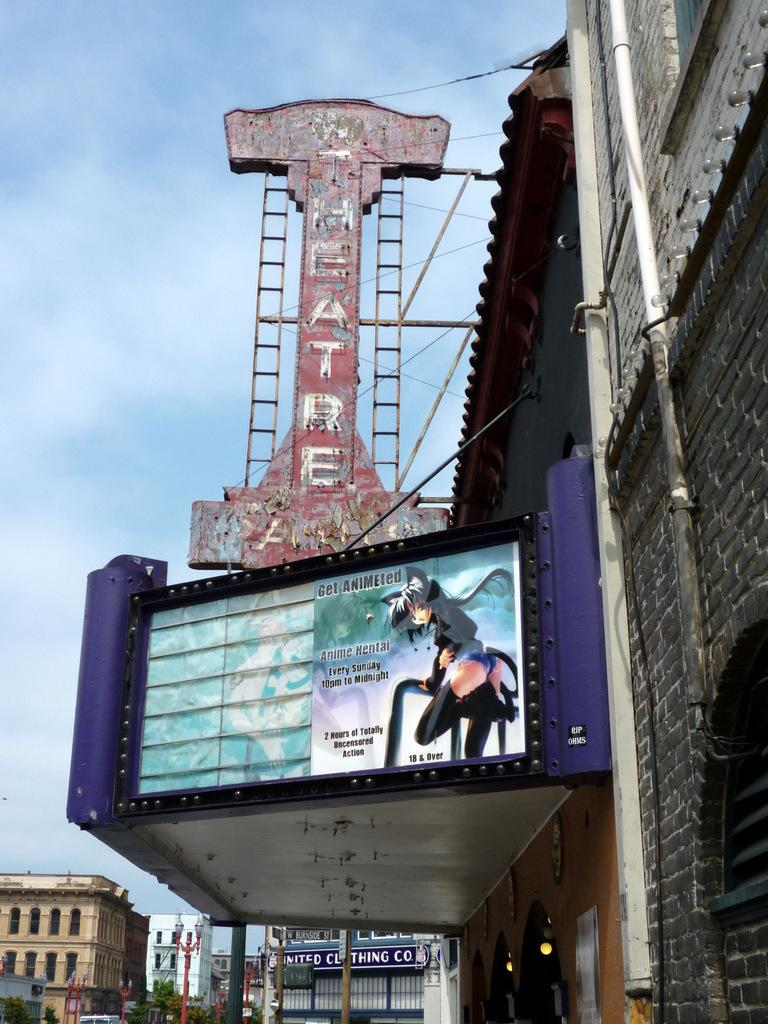Provide a one-sentence caption for the provided image. An old theater is showing anime on Sunday nights for ages 18 and over. 